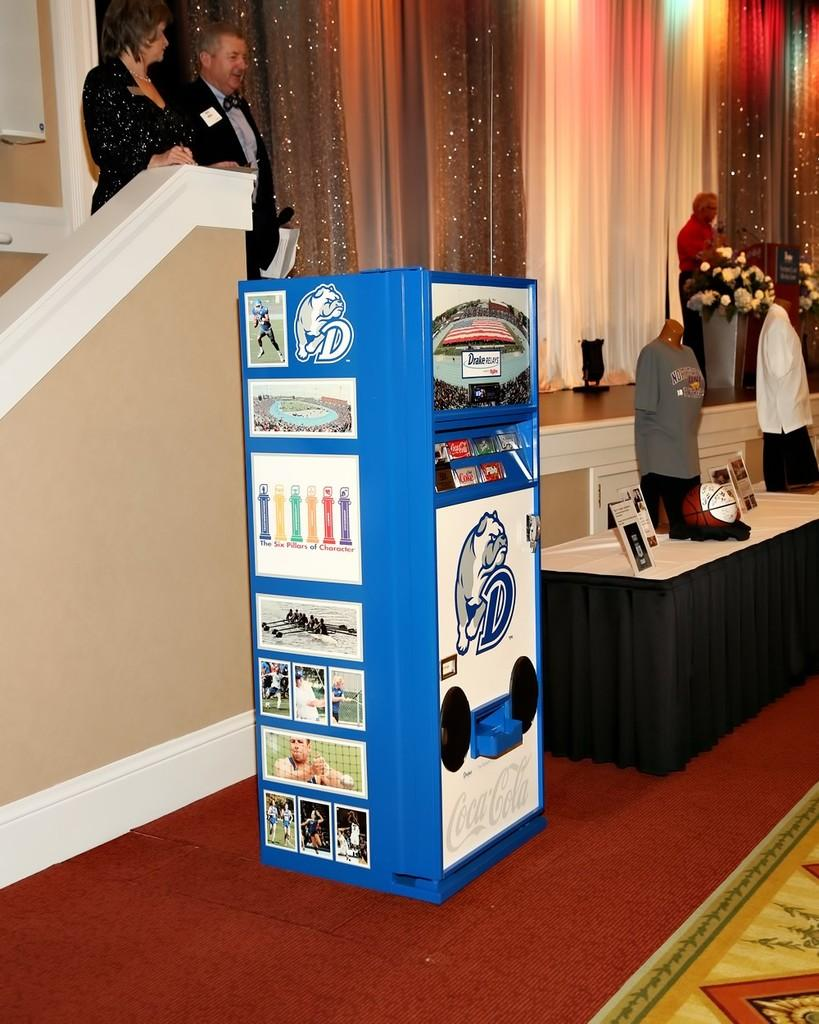How many people are present in the image? There are three people in the image. What object is associated with a sport in the image? There is a basketball in the image. What type of clothing can be seen in the image? There are shirts in the image. What piece of furniture is present in the image? There is a Coca-Cola desk in the image. What type of vegetation is on the right side of the image? There are flowers on the right side of the image. What type of mountain is visible in the background of the image? There is no mountain visible in the image; it only features three people, a basketball, shirts, a Coca-Cola desk, and flowers. What idea is being discussed by the people in the image? The image does not provide any information about an idea being discussed. 